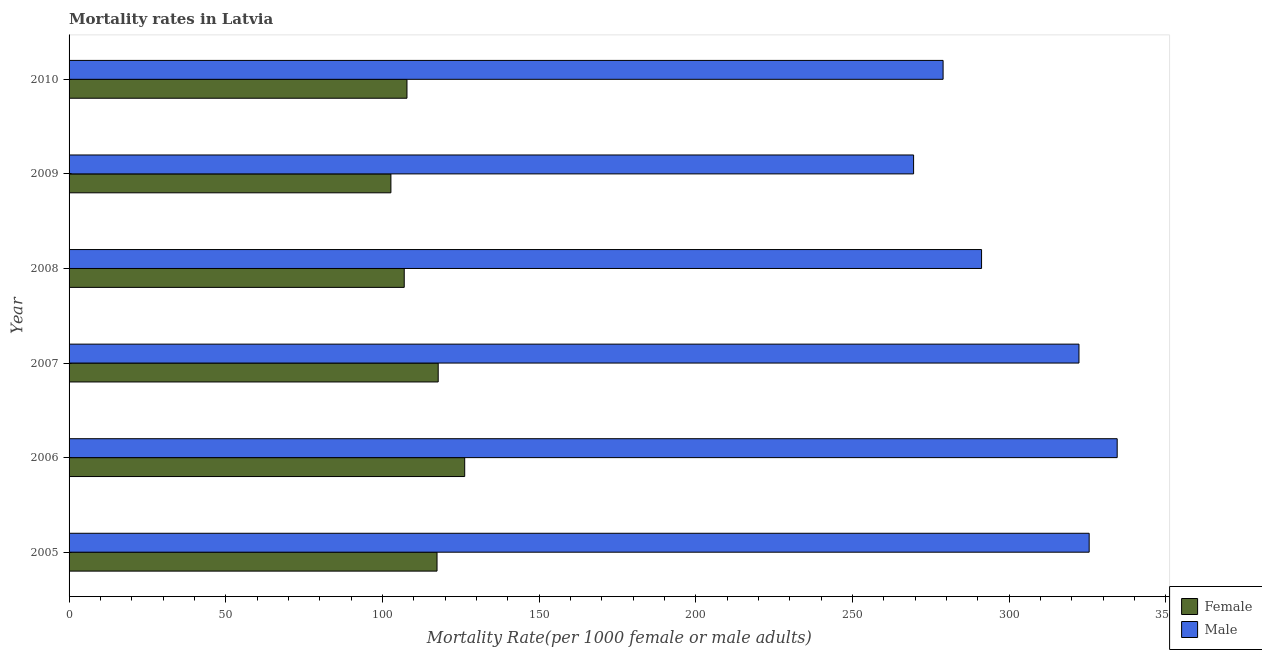How many bars are there on the 1st tick from the top?
Give a very brief answer. 2. In how many cases, is the number of bars for a given year not equal to the number of legend labels?
Offer a terse response. 0. What is the female mortality rate in 2008?
Your answer should be very brief. 106.96. Across all years, what is the maximum male mortality rate?
Make the answer very short. 334.48. Across all years, what is the minimum male mortality rate?
Your answer should be compact. 269.51. In which year was the female mortality rate maximum?
Provide a succinct answer. 2006. In which year was the female mortality rate minimum?
Provide a short and direct response. 2009. What is the total female mortality rate in the graph?
Give a very brief answer. 678.98. What is the difference between the female mortality rate in 2005 and that in 2009?
Give a very brief answer. 14.72. What is the difference between the female mortality rate in 2008 and the male mortality rate in 2010?
Offer a very short reply. -171.97. What is the average female mortality rate per year?
Your answer should be compact. 113.16. In the year 2010, what is the difference between the female mortality rate and male mortality rate?
Provide a short and direct response. -171.09. What is the ratio of the female mortality rate in 2006 to that in 2008?
Provide a succinct answer. 1.18. Is the difference between the male mortality rate in 2006 and 2010 greater than the difference between the female mortality rate in 2006 and 2010?
Provide a short and direct response. Yes. What is the difference between the highest and the second highest male mortality rate?
Your response must be concise. 8.94. What is the difference between the highest and the lowest female mortality rate?
Keep it short and to the point. 23.55. In how many years, is the female mortality rate greater than the average female mortality rate taken over all years?
Your answer should be very brief. 3. Is the sum of the male mortality rate in 2005 and 2008 greater than the maximum female mortality rate across all years?
Provide a succinct answer. Yes. What does the 2nd bar from the bottom in 2007 represents?
Offer a very short reply. Male. How many bars are there?
Make the answer very short. 12. How many years are there in the graph?
Keep it short and to the point. 6. What is the difference between two consecutive major ticks on the X-axis?
Ensure brevity in your answer.  50. Are the values on the major ticks of X-axis written in scientific E-notation?
Provide a short and direct response. No. Does the graph contain grids?
Offer a terse response. No. How are the legend labels stacked?
Give a very brief answer. Vertical. What is the title of the graph?
Ensure brevity in your answer.  Mortality rates in Latvia. What is the label or title of the X-axis?
Offer a terse response. Mortality Rate(per 1000 female or male adults). What is the label or title of the Y-axis?
Provide a short and direct response. Year. What is the Mortality Rate(per 1000 female or male adults) in Female in 2005?
Make the answer very short. 117.42. What is the Mortality Rate(per 1000 female or male adults) in Male in 2005?
Your answer should be very brief. 325.54. What is the Mortality Rate(per 1000 female or male adults) of Female in 2006?
Your answer should be very brief. 126.26. What is the Mortality Rate(per 1000 female or male adults) in Male in 2006?
Your answer should be compact. 334.48. What is the Mortality Rate(per 1000 female or male adults) in Female in 2007?
Keep it short and to the point. 117.8. What is the Mortality Rate(per 1000 female or male adults) in Male in 2007?
Your response must be concise. 322.29. What is the Mortality Rate(per 1000 female or male adults) of Female in 2008?
Your answer should be compact. 106.96. What is the Mortality Rate(per 1000 female or male adults) in Male in 2008?
Your answer should be very brief. 291.2. What is the Mortality Rate(per 1000 female or male adults) of Female in 2009?
Ensure brevity in your answer.  102.7. What is the Mortality Rate(per 1000 female or male adults) of Male in 2009?
Provide a succinct answer. 269.51. What is the Mortality Rate(per 1000 female or male adults) in Female in 2010?
Provide a short and direct response. 107.83. What is the Mortality Rate(per 1000 female or male adults) in Male in 2010?
Offer a very short reply. 278.93. Across all years, what is the maximum Mortality Rate(per 1000 female or male adults) of Female?
Give a very brief answer. 126.26. Across all years, what is the maximum Mortality Rate(per 1000 female or male adults) of Male?
Keep it short and to the point. 334.48. Across all years, what is the minimum Mortality Rate(per 1000 female or male adults) in Female?
Offer a terse response. 102.7. Across all years, what is the minimum Mortality Rate(per 1000 female or male adults) of Male?
Provide a short and direct response. 269.51. What is the total Mortality Rate(per 1000 female or male adults) in Female in the graph?
Your answer should be compact. 678.98. What is the total Mortality Rate(per 1000 female or male adults) of Male in the graph?
Offer a very short reply. 1821.95. What is the difference between the Mortality Rate(per 1000 female or male adults) in Female in 2005 and that in 2006?
Offer a very short reply. -8.83. What is the difference between the Mortality Rate(per 1000 female or male adults) of Male in 2005 and that in 2006?
Keep it short and to the point. -8.94. What is the difference between the Mortality Rate(per 1000 female or male adults) of Female in 2005 and that in 2007?
Keep it short and to the point. -0.38. What is the difference between the Mortality Rate(per 1000 female or male adults) in Male in 2005 and that in 2007?
Provide a short and direct response. 3.25. What is the difference between the Mortality Rate(per 1000 female or male adults) in Female in 2005 and that in 2008?
Make the answer very short. 10.47. What is the difference between the Mortality Rate(per 1000 female or male adults) of Male in 2005 and that in 2008?
Provide a short and direct response. 34.34. What is the difference between the Mortality Rate(per 1000 female or male adults) of Female in 2005 and that in 2009?
Give a very brief answer. 14.72. What is the difference between the Mortality Rate(per 1000 female or male adults) of Male in 2005 and that in 2009?
Your answer should be very brief. 56.03. What is the difference between the Mortality Rate(per 1000 female or male adults) in Female in 2005 and that in 2010?
Make the answer very short. 9.59. What is the difference between the Mortality Rate(per 1000 female or male adults) in Male in 2005 and that in 2010?
Your response must be concise. 46.62. What is the difference between the Mortality Rate(per 1000 female or male adults) in Female in 2006 and that in 2007?
Ensure brevity in your answer.  8.46. What is the difference between the Mortality Rate(per 1000 female or male adults) of Male in 2006 and that in 2007?
Give a very brief answer. 12.19. What is the difference between the Mortality Rate(per 1000 female or male adults) of Female in 2006 and that in 2008?
Keep it short and to the point. 19.3. What is the difference between the Mortality Rate(per 1000 female or male adults) in Male in 2006 and that in 2008?
Ensure brevity in your answer.  43.28. What is the difference between the Mortality Rate(per 1000 female or male adults) in Female in 2006 and that in 2009?
Offer a terse response. 23.55. What is the difference between the Mortality Rate(per 1000 female or male adults) of Male in 2006 and that in 2009?
Your answer should be very brief. 64.97. What is the difference between the Mortality Rate(per 1000 female or male adults) in Female in 2006 and that in 2010?
Your answer should be compact. 18.42. What is the difference between the Mortality Rate(per 1000 female or male adults) of Male in 2006 and that in 2010?
Your answer should be compact. 55.55. What is the difference between the Mortality Rate(per 1000 female or male adults) of Female in 2007 and that in 2008?
Provide a succinct answer. 10.84. What is the difference between the Mortality Rate(per 1000 female or male adults) of Male in 2007 and that in 2008?
Ensure brevity in your answer.  31.09. What is the difference between the Mortality Rate(per 1000 female or male adults) of Female in 2007 and that in 2009?
Give a very brief answer. 15.1. What is the difference between the Mortality Rate(per 1000 female or male adults) of Male in 2007 and that in 2009?
Your response must be concise. 52.77. What is the difference between the Mortality Rate(per 1000 female or male adults) of Female in 2007 and that in 2010?
Give a very brief answer. 9.97. What is the difference between the Mortality Rate(per 1000 female or male adults) of Male in 2007 and that in 2010?
Ensure brevity in your answer.  43.36. What is the difference between the Mortality Rate(per 1000 female or male adults) in Female in 2008 and that in 2009?
Keep it short and to the point. 4.25. What is the difference between the Mortality Rate(per 1000 female or male adults) of Male in 2008 and that in 2009?
Provide a short and direct response. 21.69. What is the difference between the Mortality Rate(per 1000 female or male adults) in Female in 2008 and that in 2010?
Give a very brief answer. -0.88. What is the difference between the Mortality Rate(per 1000 female or male adults) in Male in 2008 and that in 2010?
Keep it short and to the point. 12.27. What is the difference between the Mortality Rate(per 1000 female or male adults) of Female in 2009 and that in 2010?
Keep it short and to the point. -5.13. What is the difference between the Mortality Rate(per 1000 female or male adults) in Male in 2009 and that in 2010?
Provide a short and direct response. -9.41. What is the difference between the Mortality Rate(per 1000 female or male adults) of Female in 2005 and the Mortality Rate(per 1000 female or male adults) of Male in 2006?
Give a very brief answer. -217.06. What is the difference between the Mortality Rate(per 1000 female or male adults) in Female in 2005 and the Mortality Rate(per 1000 female or male adults) in Male in 2007?
Offer a very short reply. -204.86. What is the difference between the Mortality Rate(per 1000 female or male adults) in Female in 2005 and the Mortality Rate(per 1000 female or male adults) in Male in 2008?
Make the answer very short. -173.78. What is the difference between the Mortality Rate(per 1000 female or male adults) of Female in 2005 and the Mortality Rate(per 1000 female or male adults) of Male in 2009?
Offer a very short reply. -152.09. What is the difference between the Mortality Rate(per 1000 female or male adults) of Female in 2005 and the Mortality Rate(per 1000 female or male adults) of Male in 2010?
Provide a succinct answer. -161.5. What is the difference between the Mortality Rate(per 1000 female or male adults) of Female in 2006 and the Mortality Rate(per 1000 female or male adults) of Male in 2007?
Provide a short and direct response. -196.03. What is the difference between the Mortality Rate(per 1000 female or male adults) in Female in 2006 and the Mortality Rate(per 1000 female or male adults) in Male in 2008?
Offer a very short reply. -164.94. What is the difference between the Mortality Rate(per 1000 female or male adults) in Female in 2006 and the Mortality Rate(per 1000 female or male adults) in Male in 2009?
Ensure brevity in your answer.  -143.25. What is the difference between the Mortality Rate(per 1000 female or male adults) in Female in 2006 and the Mortality Rate(per 1000 female or male adults) in Male in 2010?
Keep it short and to the point. -152.67. What is the difference between the Mortality Rate(per 1000 female or male adults) of Female in 2007 and the Mortality Rate(per 1000 female or male adults) of Male in 2008?
Give a very brief answer. -173.4. What is the difference between the Mortality Rate(per 1000 female or male adults) in Female in 2007 and the Mortality Rate(per 1000 female or male adults) in Male in 2009?
Keep it short and to the point. -151.71. What is the difference between the Mortality Rate(per 1000 female or male adults) in Female in 2007 and the Mortality Rate(per 1000 female or male adults) in Male in 2010?
Provide a succinct answer. -161.13. What is the difference between the Mortality Rate(per 1000 female or male adults) of Female in 2008 and the Mortality Rate(per 1000 female or male adults) of Male in 2009?
Your answer should be compact. -162.56. What is the difference between the Mortality Rate(per 1000 female or male adults) of Female in 2008 and the Mortality Rate(per 1000 female or male adults) of Male in 2010?
Offer a very short reply. -171.97. What is the difference between the Mortality Rate(per 1000 female or male adults) in Female in 2009 and the Mortality Rate(per 1000 female or male adults) in Male in 2010?
Make the answer very short. -176.22. What is the average Mortality Rate(per 1000 female or male adults) in Female per year?
Give a very brief answer. 113.16. What is the average Mortality Rate(per 1000 female or male adults) in Male per year?
Your answer should be compact. 303.66. In the year 2005, what is the difference between the Mortality Rate(per 1000 female or male adults) in Female and Mortality Rate(per 1000 female or male adults) in Male?
Your answer should be very brief. -208.12. In the year 2006, what is the difference between the Mortality Rate(per 1000 female or male adults) of Female and Mortality Rate(per 1000 female or male adults) of Male?
Offer a terse response. -208.22. In the year 2007, what is the difference between the Mortality Rate(per 1000 female or male adults) in Female and Mortality Rate(per 1000 female or male adults) in Male?
Offer a very short reply. -204.49. In the year 2008, what is the difference between the Mortality Rate(per 1000 female or male adults) in Female and Mortality Rate(per 1000 female or male adults) in Male?
Ensure brevity in your answer.  -184.24. In the year 2009, what is the difference between the Mortality Rate(per 1000 female or male adults) in Female and Mortality Rate(per 1000 female or male adults) in Male?
Make the answer very short. -166.81. In the year 2010, what is the difference between the Mortality Rate(per 1000 female or male adults) of Female and Mortality Rate(per 1000 female or male adults) of Male?
Ensure brevity in your answer.  -171.09. What is the ratio of the Mortality Rate(per 1000 female or male adults) of Male in 2005 to that in 2006?
Provide a succinct answer. 0.97. What is the ratio of the Mortality Rate(per 1000 female or male adults) in Female in 2005 to that in 2008?
Keep it short and to the point. 1.1. What is the ratio of the Mortality Rate(per 1000 female or male adults) of Male in 2005 to that in 2008?
Offer a very short reply. 1.12. What is the ratio of the Mortality Rate(per 1000 female or male adults) of Female in 2005 to that in 2009?
Give a very brief answer. 1.14. What is the ratio of the Mortality Rate(per 1000 female or male adults) in Male in 2005 to that in 2009?
Offer a terse response. 1.21. What is the ratio of the Mortality Rate(per 1000 female or male adults) in Female in 2005 to that in 2010?
Make the answer very short. 1.09. What is the ratio of the Mortality Rate(per 1000 female or male adults) of Male in 2005 to that in 2010?
Keep it short and to the point. 1.17. What is the ratio of the Mortality Rate(per 1000 female or male adults) of Female in 2006 to that in 2007?
Offer a very short reply. 1.07. What is the ratio of the Mortality Rate(per 1000 female or male adults) of Male in 2006 to that in 2007?
Your answer should be very brief. 1.04. What is the ratio of the Mortality Rate(per 1000 female or male adults) of Female in 2006 to that in 2008?
Give a very brief answer. 1.18. What is the ratio of the Mortality Rate(per 1000 female or male adults) of Male in 2006 to that in 2008?
Ensure brevity in your answer.  1.15. What is the ratio of the Mortality Rate(per 1000 female or male adults) in Female in 2006 to that in 2009?
Your response must be concise. 1.23. What is the ratio of the Mortality Rate(per 1000 female or male adults) of Male in 2006 to that in 2009?
Your response must be concise. 1.24. What is the ratio of the Mortality Rate(per 1000 female or male adults) of Female in 2006 to that in 2010?
Your answer should be compact. 1.17. What is the ratio of the Mortality Rate(per 1000 female or male adults) in Male in 2006 to that in 2010?
Provide a succinct answer. 1.2. What is the ratio of the Mortality Rate(per 1000 female or male adults) of Female in 2007 to that in 2008?
Your answer should be compact. 1.1. What is the ratio of the Mortality Rate(per 1000 female or male adults) of Male in 2007 to that in 2008?
Give a very brief answer. 1.11. What is the ratio of the Mortality Rate(per 1000 female or male adults) in Female in 2007 to that in 2009?
Provide a short and direct response. 1.15. What is the ratio of the Mortality Rate(per 1000 female or male adults) in Male in 2007 to that in 2009?
Keep it short and to the point. 1.2. What is the ratio of the Mortality Rate(per 1000 female or male adults) in Female in 2007 to that in 2010?
Keep it short and to the point. 1.09. What is the ratio of the Mortality Rate(per 1000 female or male adults) in Male in 2007 to that in 2010?
Give a very brief answer. 1.16. What is the ratio of the Mortality Rate(per 1000 female or male adults) in Female in 2008 to that in 2009?
Your answer should be very brief. 1.04. What is the ratio of the Mortality Rate(per 1000 female or male adults) of Male in 2008 to that in 2009?
Make the answer very short. 1.08. What is the ratio of the Mortality Rate(per 1000 female or male adults) of Female in 2008 to that in 2010?
Your response must be concise. 0.99. What is the ratio of the Mortality Rate(per 1000 female or male adults) in Male in 2008 to that in 2010?
Offer a terse response. 1.04. What is the ratio of the Mortality Rate(per 1000 female or male adults) in Female in 2009 to that in 2010?
Make the answer very short. 0.95. What is the ratio of the Mortality Rate(per 1000 female or male adults) in Male in 2009 to that in 2010?
Your answer should be very brief. 0.97. What is the difference between the highest and the second highest Mortality Rate(per 1000 female or male adults) in Female?
Provide a short and direct response. 8.46. What is the difference between the highest and the second highest Mortality Rate(per 1000 female or male adults) in Male?
Offer a very short reply. 8.94. What is the difference between the highest and the lowest Mortality Rate(per 1000 female or male adults) in Female?
Keep it short and to the point. 23.55. What is the difference between the highest and the lowest Mortality Rate(per 1000 female or male adults) in Male?
Provide a succinct answer. 64.97. 